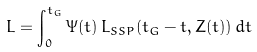<formula> <loc_0><loc_0><loc_500><loc_500>L = \int _ { 0 } ^ { t _ { G } } \Psi ( t ) \, L _ { S S P } ( t _ { G } - t , Z ( t ) ) \, d t</formula> 